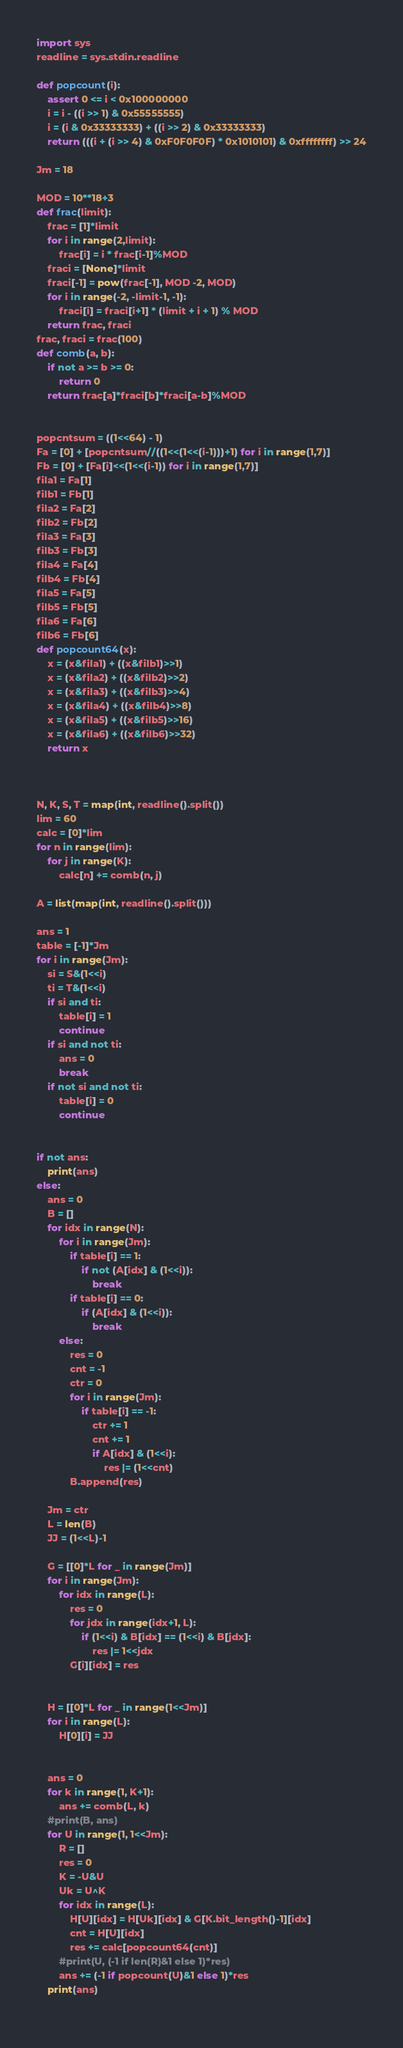<code> <loc_0><loc_0><loc_500><loc_500><_Python_>import sys
readline = sys.stdin.readline

def popcount(i):
    assert 0 <= i < 0x100000000
    i = i - ((i >> 1) & 0x55555555)
    i = (i & 0x33333333) + ((i >> 2) & 0x33333333)
    return (((i + (i >> 4) & 0xF0F0F0F) * 0x1010101) & 0xffffffff) >> 24

Jm = 18

MOD = 10**18+3
def frac(limit):
    frac = [1]*limit
    for i in range(2,limit):
        frac[i] = i * frac[i-1]%MOD
    fraci = [None]*limit
    fraci[-1] = pow(frac[-1], MOD -2, MOD)
    for i in range(-2, -limit-1, -1):
        fraci[i] = fraci[i+1] * (limit + i + 1) % MOD
    return frac, fraci
frac, fraci = frac(100)
def comb(a, b):
    if not a >= b >= 0:
        return 0
    return frac[a]*fraci[b]*fraci[a-b]%MOD


popcntsum = ((1<<64) - 1)
Fa = [0] + [popcntsum//((1<<(1<<(i-1)))+1) for i in range(1,7)]
Fb = [0] + [Fa[i]<<(1<<(i-1)) for i in range(1,7)]
fila1 = Fa[1]
filb1 = Fb[1]
fila2 = Fa[2]
filb2 = Fb[2]
fila3 = Fa[3]
filb3 = Fb[3]
fila4 = Fa[4]
filb4 = Fb[4]
fila5 = Fa[5]
filb5 = Fb[5]
fila6 = Fa[6]
filb6 = Fb[6]
def popcount64(x):
    x = (x&fila1) + ((x&filb1)>>1)
    x = (x&fila2) + ((x&filb2)>>2)
    x = (x&fila3) + ((x&filb3)>>4)
    x = (x&fila4) + ((x&filb4)>>8)
    x = (x&fila5) + ((x&filb5)>>16)
    x = (x&fila6) + ((x&filb6)>>32)
    return x



N, K, S, T = map(int, readline().split())
lim = 60
calc = [0]*lim
for n in range(lim):
    for j in range(K):
        calc[n] += comb(n, j)

A = list(map(int, readline().split()))

ans = 1
table = [-1]*Jm
for i in range(Jm):
    si = S&(1<<i)
    ti = T&(1<<i)
    if si and ti:
        table[i] = 1
        continue
    if si and not ti:
        ans = 0
        break
    if not si and not ti:
        table[i] = 0
        continue        


if not ans:
    print(ans)
else:
    ans = 0
    B = []
    for idx in range(N):
        for i in range(Jm):
            if table[i] == 1:
                if not (A[idx] & (1<<i)):
                    break
            if table[i] == 0:
                if (A[idx] & (1<<i)):
                    break
        else:
            res = 0
            cnt = -1
            ctr = 0
            for i in range(Jm):
                if table[i] == -1:
                    ctr += 1
                    cnt += 1
                    if A[idx] & (1<<i):
                        res |= (1<<cnt)
            B.append(res)
    
    Jm = ctr
    L = len(B)
    JJ = (1<<L)-1

    G = [[0]*L for _ in range(Jm)]
    for i in range(Jm):
        for idx in range(L):
            res = 0
            for jdx in range(idx+1, L):
                if (1<<i) & B[idx] == (1<<i) & B[jdx]:
                    res |= 1<<jdx
            G[i][idx] = res
    
    
    H = [[0]*L for _ in range(1<<Jm)]
    for i in range(L):
        H[0][i] = JJ
    
    
    ans = 0
    for k in range(1, K+1):
        ans += comb(L, k)
    #print(B, ans)
    for U in range(1, 1<<Jm):
        R = []
        res = 0
        K = -U&U
        Uk = U^K
        for idx in range(L):
            H[U][idx] = H[Uk][idx] & G[K.bit_length()-1][idx]
            cnt = H[U][idx]
            res += calc[popcount64(cnt)]
        #print(U, (-1 if len(R)&1 else 1)*res)
        ans += (-1 if popcount(U)&1 else 1)*res
    print(ans)
        </code> 